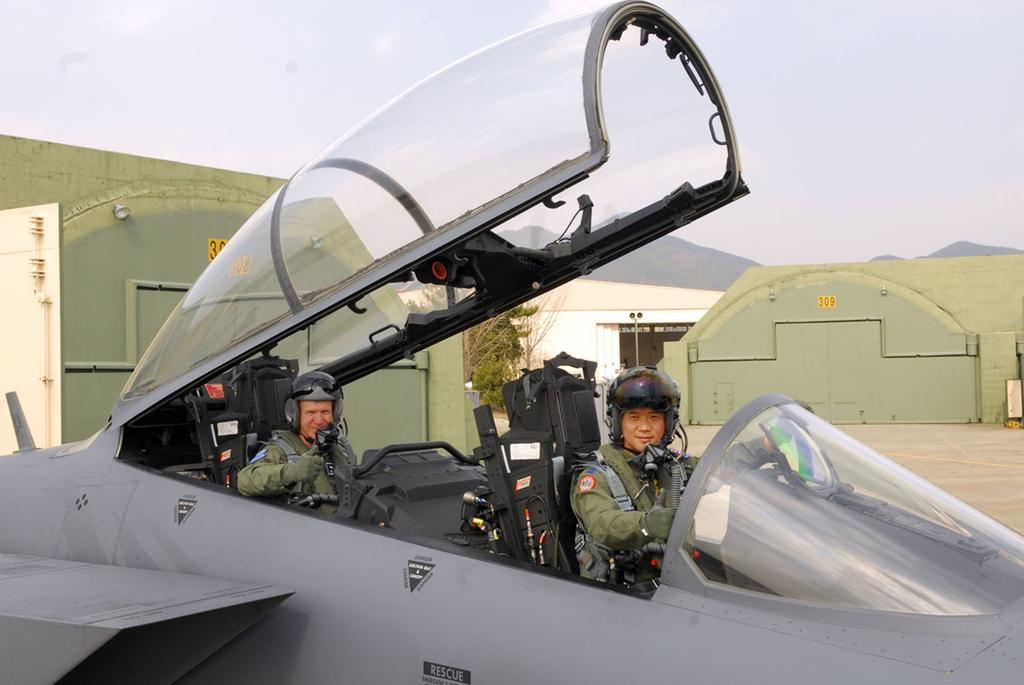<image>
Relay a brief, clear account of the picture shown. The plane has a small sign on the side that says rescue. 